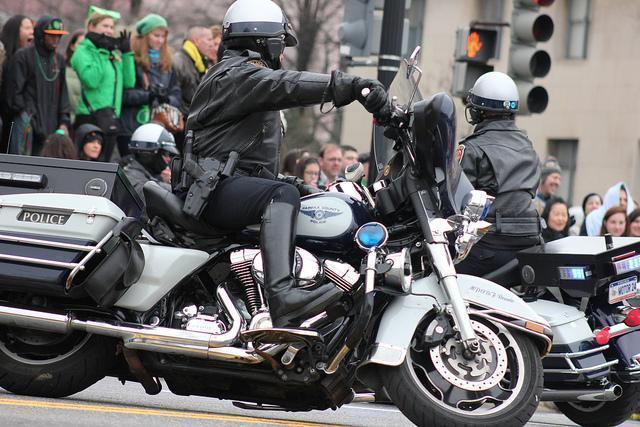Ignoring everything else about the image what should pedestrians do about crossing the street according to the traffic light?
From the following set of four choices, select the accurate answer to respond to the question.
Options: Go around, wait, cross, give up. Wait. 